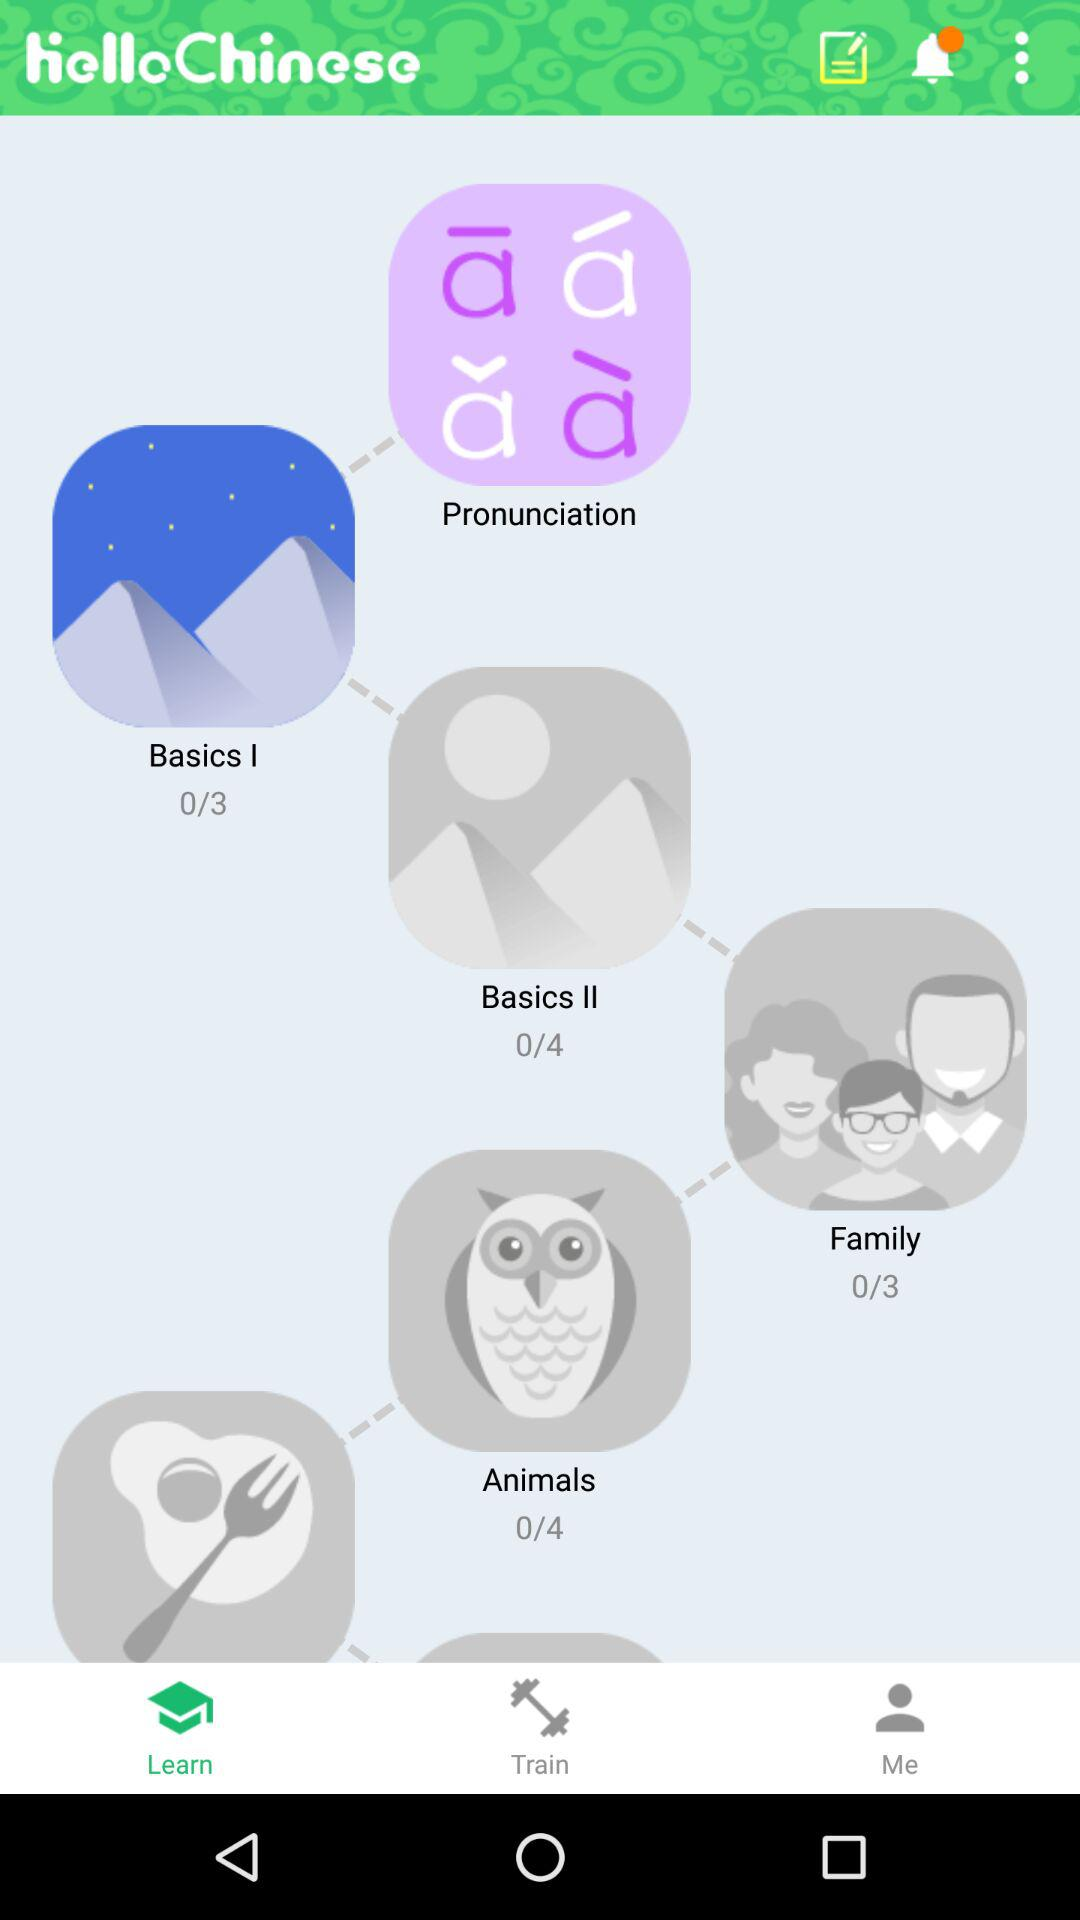What is the number of chapters in "Family"? The number of chapters in "Family" is 3. 